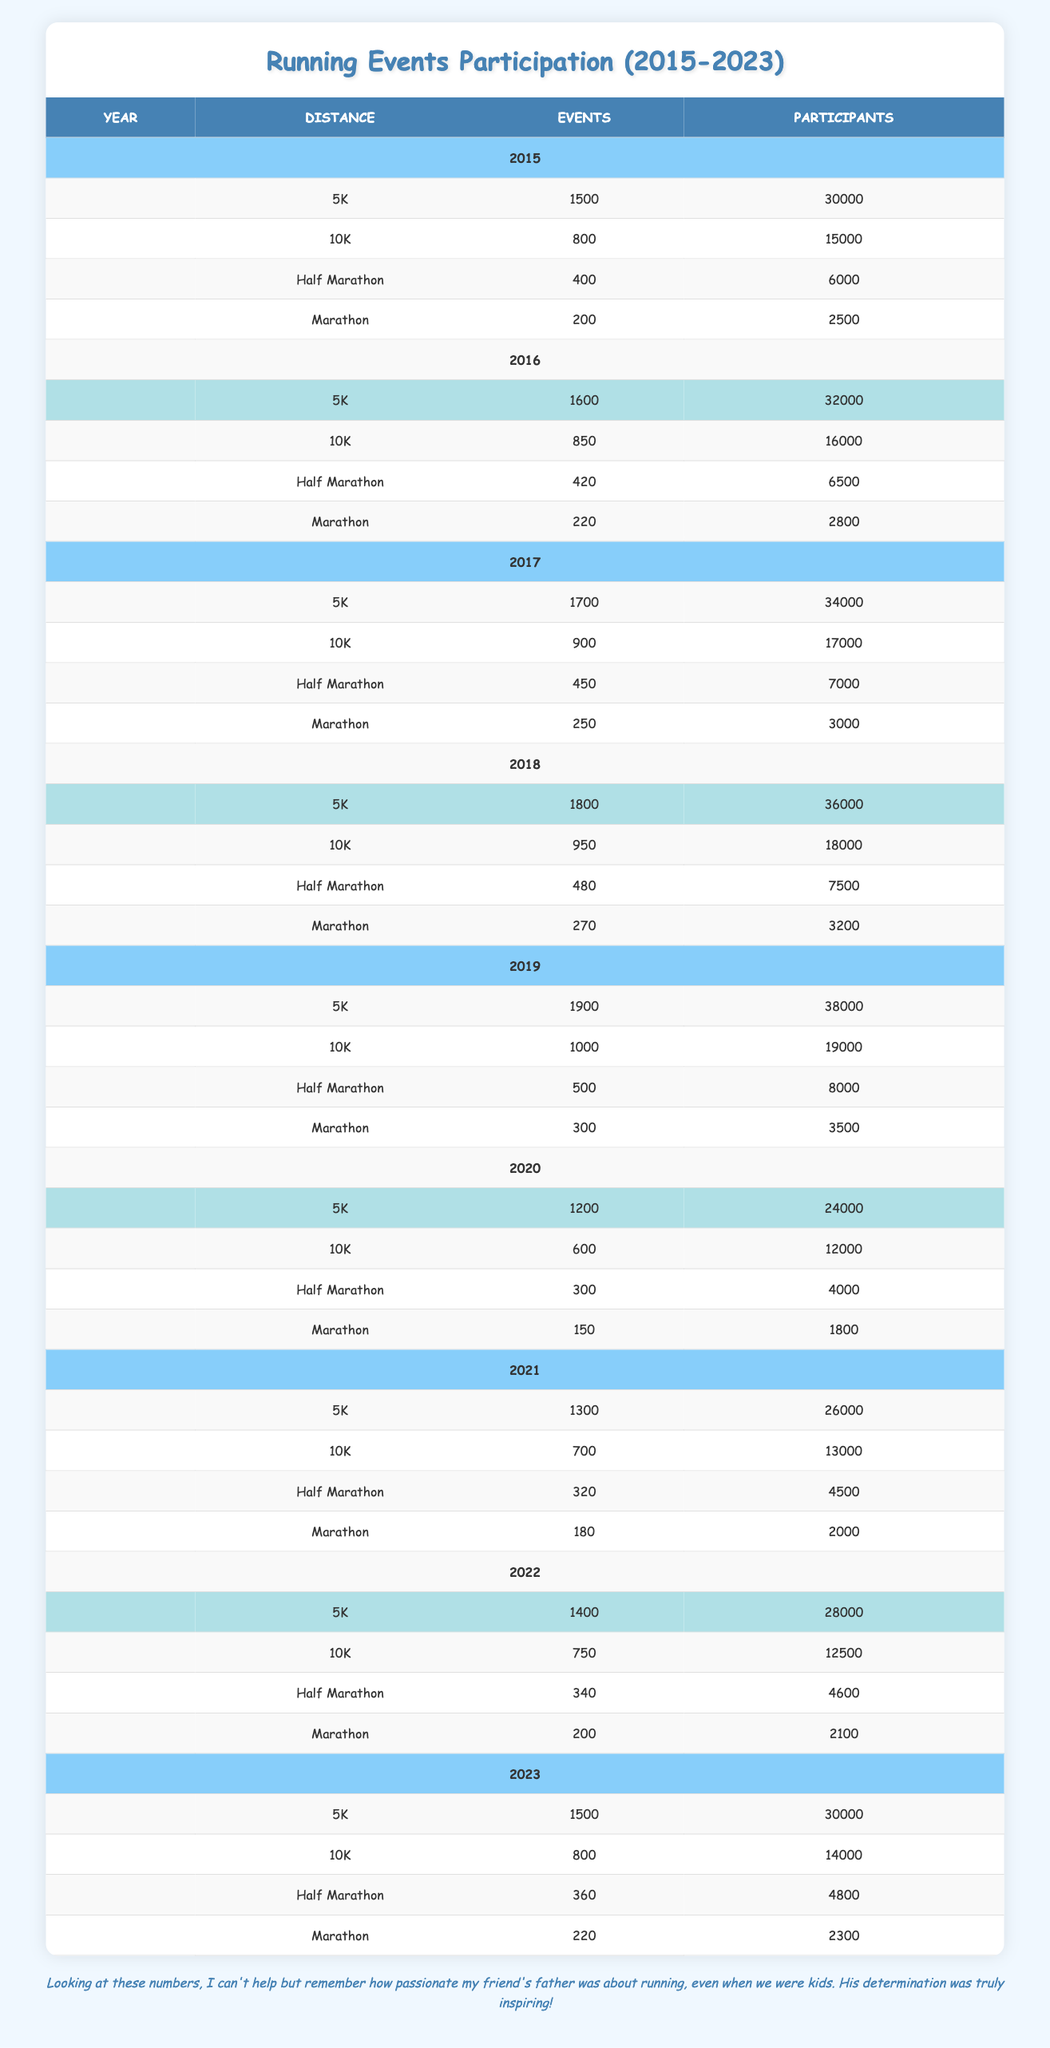What was the total number of participants in 5K events from 2015 to 2023? To find the total number of participants in 5K events over the years, I will add the participants from each year: 30000 + 32000 + 34000 + 36000 + 38000 + 24000 + 26000 + 28000 + 30000 = 195000.
Answer: 195000 Which year had the highest number of Marathon events? Looking at the table, I can see the number of Marathon events by year: 200 (2015), 220 (2016), 250 (2017), 270 (2018), 300 (2019), 150 (2020), 180 (2021), 200 (2022), and 220 (2023). The year 2019 had the highest number of events, which is 300.
Answer: 2019 Did the number of participants in the 10K distance increase from 2015 to 2019? The participants in 10K events by year are: 15000 (2015), 16000 (2016), 17000 (2017), 18000 (2018), and 19000 (2019). Since the numbers are increasing each year, the answer is yes.
Answer: Yes What is the average number of participants in Half Marathons from 2015 to 2023? I will sum up the number of participants in Half Marathon events over the years: 6000 + 6500 + 7000 + 7500 + 8000 + 4000 + 4500 + 4600 + 4800 = 43500. There are 9 years, so the average number of participants is 43500 / 9 ≈ 4833.33.
Answer: Approximately 4833 Which year saw the most participants in overall running events combined? To find the year with the most overall participants, I will sum the participants of all distances in each year: 30000 + 15000 + 6000 + 2500 (2015) = 52500, 32000 + 16000 + 6500 + 2800 (2016) = 56400, 34000 + 17000 + 7000 + 3000 (2017) = 60900, 36000 + 18000 + 7500 + 3200 (2018) = 63400, 38000 + 19000 + 8000 + 3500 (2019) = 63300, 24000 + 12000 + 4000 + 1800 (2020) = 40000, 26000 + 13000 + 4500 + 2000 (2021) = 49500, 28000 + 12500 + 4600 + 2100 (2022) = 42000, and 30000 + 14000 + 4800 + 2300 (2023) = 51100. The highest total participants were 63400 in 2018.
Answer: 2018 Did the number of events for the 10K category decrease from 2019 to 2021? The events for the 10K category in those years were 1000 (2019) and 700 (2021). Since 700 is less than 1000, it confirms a decrease.
Answer: Yes 